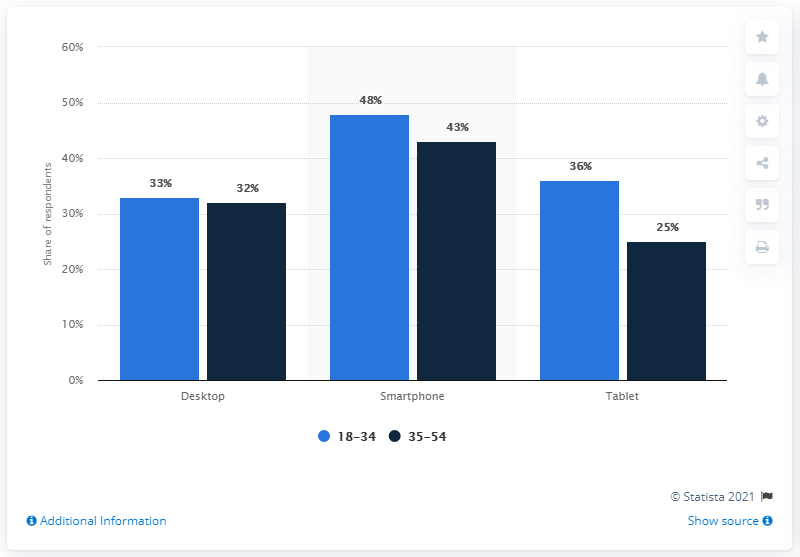Indicate a few pertinent items in this graphic. According to a survey conducted in April 2016, 61% of connected consumers felt that there were too many ads on their tablet. According to a survey conducted in April 2016, a significant number of connected consumers, 11%, felt that there were too many ads on their tablet. 